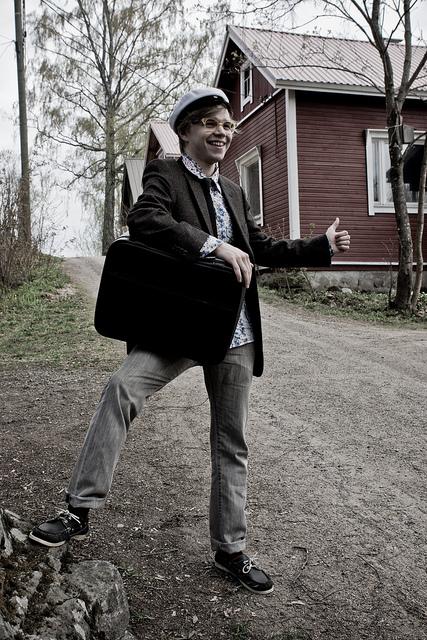What pattern is on the boy's shirt?
Write a very short answer. Plaid. Is the image in black and white?
Answer briefly. No. What is the man doing with his left hand?
Keep it brief. Hitchhiking. Is this man staying at this house today?
Quick response, please. No. 